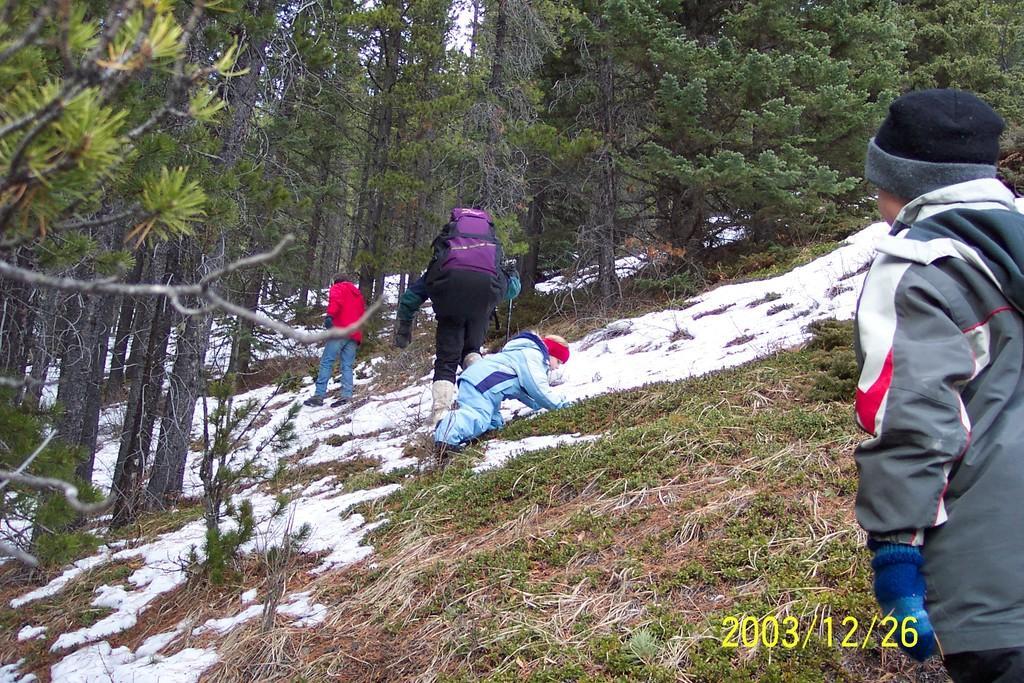Describe this image in one or two sentences. In this picture we can see few people, in the middle of the image we can see a person and the person wore a bag, in the background we can find few trees and snow, at the right bottom of the image we can see timestamp. 